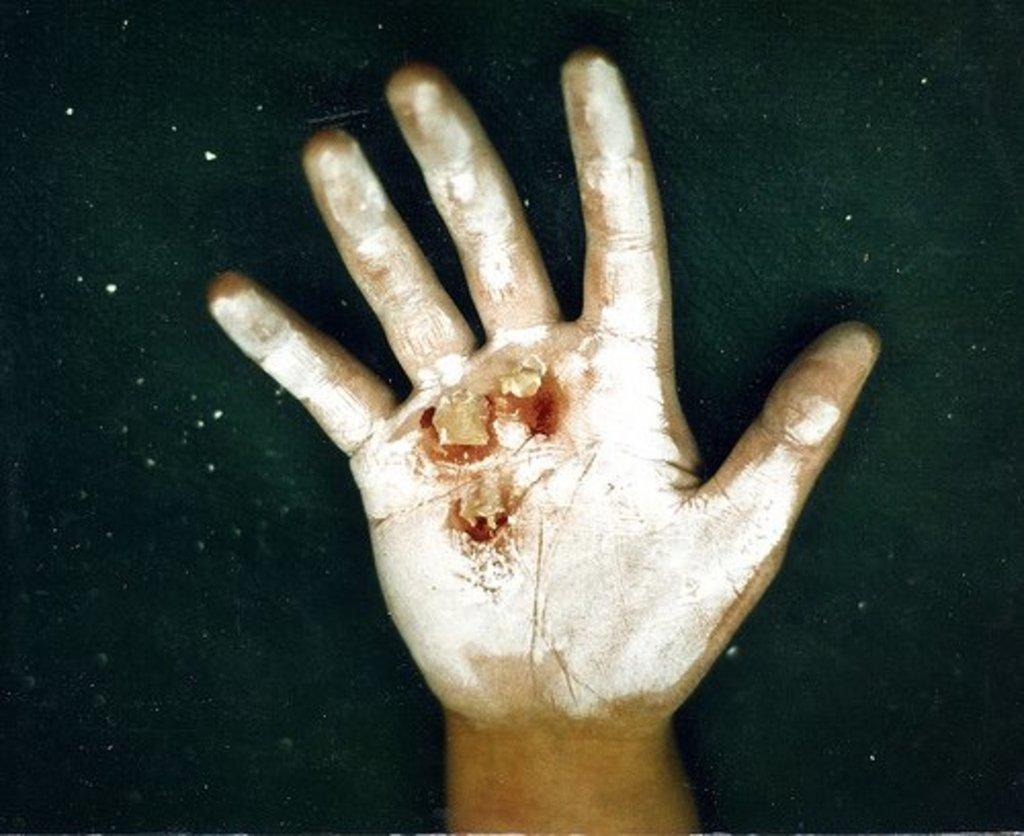Please provide a concise description of this image. In this image there is a person's hand visible. On the hand, there is some injury. Background is in black color. 